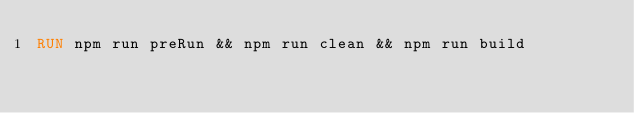Convert code to text. <code><loc_0><loc_0><loc_500><loc_500><_Dockerfile_>RUN npm run preRun && npm run clean && npm run build

</code> 